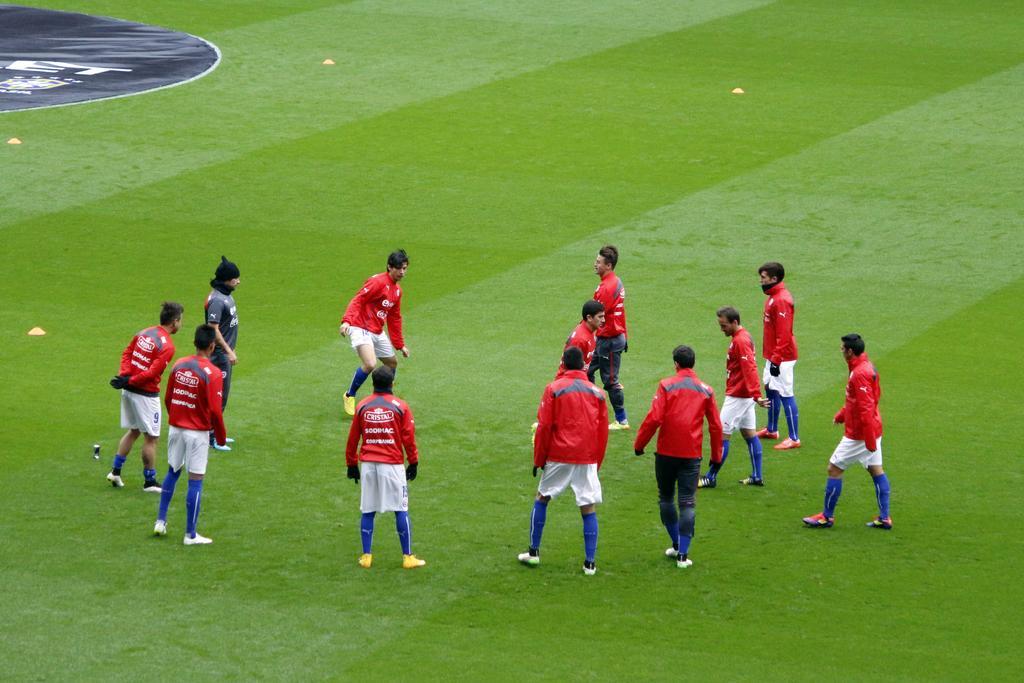In one or two sentences, can you explain what this image depicts? This is the picture of a playground. In this image there are group of people standing with the red t-shirts and there is a person with black t-shirt. At the bottom there is grass. 